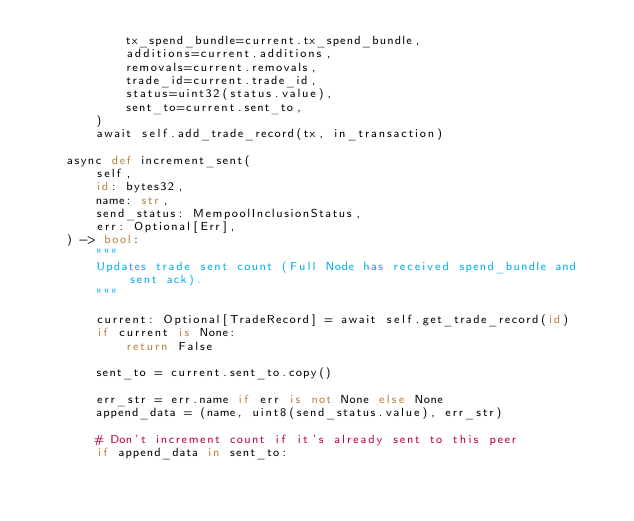<code> <loc_0><loc_0><loc_500><loc_500><_Python_>            tx_spend_bundle=current.tx_spend_bundle,
            additions=current.additions,
            removals=current.removals,
            trade_id=current.trade_id,
            status=uint32(status.value),
            sent_to=current.sent_to,
        )
        await self.add_trade_record(tx, in_transaction)

    async def increment_sent(
        self,
        id: bytes32,
        name: str,
        send_status: MempoolInclusionStatus,
        err: Optional[Err],
    ) -> bool:
        """
        Updates trade sent count (Full Node has received spend_bundle and sent ack).
        """

        current: Optional[TradeRecord] = await self.get_trade_record(id)
        if current is None:
            return False

        sent_to = current.sent_to.copy()

        err_str = err.name if err is not None else None
        append_data = (name, uint8(send_status.value), err_str)

        # Don't increment count if it's already sent to this peer
        if append_data in sent_to:</code> 